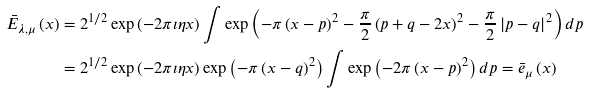<formula> <loc_0><loc_0><loc_500><loc_500>\bar { E } _ { \lambda , \mu } \left ( x \right ) & = 2 ^ { 1 / 2 } \exp \left ( - 2 \pi \imath \eta x \right ) \int \exp \left ( - \pi \left ( x - p \right ) ^ { 2 } - \frac { \pi } { 2 } \left ( p + q - 2 x \right ) ^ { 2 } - \frac { \pi } { 2 } \left | p - q \right | ^ { 2 } \right ) d p \\ & = 2 ^ { 1 / 2 } \exp \left ( - 2 \pi \imath \eta x \right ) \exp \left ( - \pi \left ( x - q \right ) ^ { 2 } \right ) \int \exp \left ( - 2 \pi \left ( x - p \right ) ^ { 2 } \right ) d p = \bar { e } _ { \mu } \left ( x \right )</formula> 